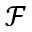<formula> <loc_0><loc_0><loc_500><loc_500>\mathcal { F }</formula> 